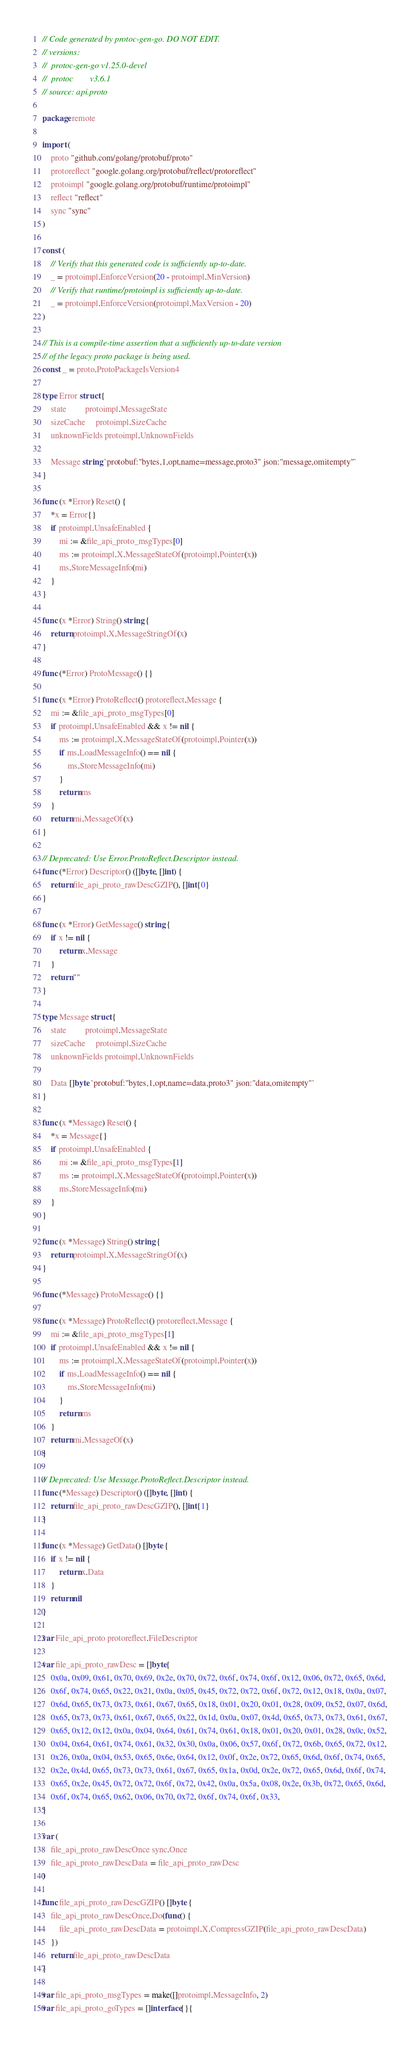<code> <loc_0><loc_0><loc_500><loc_500><_Go_>// Code generated by protoc-gen-go. DO NOT EDIT.
// versions:
// 	protoc-gen-go v1.25.0-devel
// 	protoc        v3.6.1
// source: api.proto

package remote

import (
	proto "github.com/golang/protobuf/proto"
	protoreflect "google.golang.org/protobuf/reflect/protoreflect"
	protoimpl "google.golang.org/protobuf/runtime/protoimpl"
	reflect "reflect"
	sync "sync"
)

const (
	// Verify that this generated code is sufficiently up-to-date.
	_ = protoimpl.EnforceVersion(20 - protoimpl.MinVersion)
	// Verify that runtime/protoimpl is sufficiently up-to-date.
	_ = protoimpl.EnforceVersion(protoimpl.MaxVersion - 20)
)

// This is a compile-time assertion that a sufficiently up-to-date version
// of the legacy proto package is being used.
const _ = proto.ProtoPackageIsVersion4

type Error struct {
	state         protoimpl.MessageState
	sizeCache     protoimpl.SizeCache
	unknownFields protoimpl.UnknownFields

	Message string `protobuf:"bytes,1,opt,name=message,proto3" json:"message,omitempty"`
}

func (x *Error) Reset() {
	*x = Error{}
	if protoimpl.UnsafeEnabled {
		mi := &file_api_proto_msgTypes[0]
		ms := protoimpl.X.MessageStateOf(protoimpl.Pointer(x))
		ms.StoreMessageInfo(mi)
	}
}

func (x *Error) String() string {
	return protoimpl.X.MessageStringOf(x)
}

func (*Error) ProtoMessage() {}

func (x *Error) ProtoReflect() protoreflect.Message {
	mi := &file_api_proto_msgTypes[0]
	if protoimpl.UnsafeEnabled && x != nil {
		ms := protoimpl.X.MessageStateOf(protoimpl.Pointer(x))
		if ms.LoadMessageInfo() == nil {
			ms.StoreMessageInfo(mi)
		}
		return ms
	}
	return mi.MessageOf(x)
}

// Deprecated: Use Error.ProtoReflect.Descriptor instead.
func (*Error) Descriptor() ([]byte, []int) {
	return file_api_proto_rawDescGZIP(), []int{0}
}

func (x *Error) GetMessage() string {
	if x != nil {
		return x.Message
	}
	return ""
}

type Message struct {
	state         protoimpl.MessageState
	sizeCache     protoimpl.SizeCache
	unknownFields protoimpl.UnknownFields

	Data []byte `protobuf:"bytes,1,opt,name=data,proto3" json:"data,omitempty"`
}

func (x *Message) Reset() {
	*x = Message{}
	if protoimpl.UnsafeEnabled {
		mi := &file_api_proto_msgTypes[1]
		ms := protoimpl.X.MessageStateOf(protoimpl.Pointer(x))
		ms.StoreMessageInfo(mi)
	}
}

func (x *Message) String() string {
	return protoimpl.X.MessageStringOf(x)
}

func (*Message) ProtoMessage() {}

func (x *Message) ProtoReflect() protoreflect.Message {
	mi := &file_api_proto_msgTypes[1]
	if protoimpl.UnsafeEnabled && x != nil {
		ms := protoimpl.X.MessageStateOf(protoimpl.Pointer(x))
		if ms.LoadMessageInfo() == nil {
			ms.StoreMessageInfo(mi)
		}
		return ms
	}
	return mi.MessageOf(x)
}

// Deprecated: Use Message.ProtoReflect.Descriptor instead.
func (*Message) Descriptor() ([]byte, []int) {
	return file_api_proto_rawDescGZIP(), []int{1}
}

func (x *Message) GetData() []byte {
	if x != nil {
		return x.Data
	}
	return nil
}

var File_api_proto protoreflect.FileDescriptor

var file_api_proto_rawDesc = []byte{
	0x0a, 0x09, 0x61, 0x70, 0x69, 0x2e, 0x70, 0x72, 0x6f, 0x74, 0x6f, 0x12, 0x06, 0x72, 0x65, 0x6d,
	0x6f, 0x74, 0x65, 0x22, 0x21, 0x0a, 0x05, 0x45, 0x72, 0x72, 0x6f, 0x72, 0x12, 0x18, 0x0a, 0x07,
	0x6d, 0x65, 0x73, 0x73, 0x61, 0x67, 0x65, 0x18, 0x01, 0x20, 0x01, 0x28, 0x09, 0x52, 0x07, 0x6d,
	0x65, 0x73, 0x73, 0x61, 0x67, 0x65, 0x22, 0x1d, 0x0a, 0x07, 0x4d, 0x65, 0x73, 0x73, 0x61, 0x67,
	0x65, 0x12, 0x12, 0x0a, 0x04, 0x64, 0x61, 0x74, 0x61, 0x18, 0x01, 0x20, 0x01, 0x28, 0x0c, 0x52,
	0x04, 0x64, 0x61, 0x74, 0x61, 0x32, 0x30, 0x0a, 0x06, 0x57, 0x6f, 0x72, 0x6b, 0x65, 0x72, 0x12,
	0x26, 0x0a, 0x04, 0x53, 0x65, 0x6e, 0x64, 0x12, 0x0f, 0x2e, 0x72, 0x65, 0x6d, 0x6f, 0x74, 0x65,
	0x2e, 0x4d, 0x65, 0x73, 0x73, 0x61, 0x67, 0x65, 0x1a, 0x0d, 0x2e, 0x72, 0x65, 0x6d, 0x6f, 0x74,
	0x65, 0x2e, 0x45, 0x72, 0x72, 0x6f, 0x72, 0x42, 0x0a, 0x5a, 0x08, 0x2e, 0x3b, 0x72, 0x65, 0x6d,
	0x6f, 0x74, 0x65, 0x62, 0x06, 0x70, 0x72, 0x6f, 0x74, 0x6f, 0x33,
}

var (
	file_api_proto_rawDescOnce sync.Once
	file_api_proto_rawDescData = file_api_proto_rawDesc
)

func file_api_proto_rawDescGZIP() []byte {
	file_api_proto_rawDescOnce.Do(func() {
		file_api_proto_rawDescData = protoimpl.X.CompressGZIP(file_api_proto_rawDescData)
	})
	return file_api_proto_rawDescData
}

var file_api_proto_msgTypes = make([]protoimpl.MessageInfo, 2)
var file_api_proto_goTypes = []interface{}{</code> 